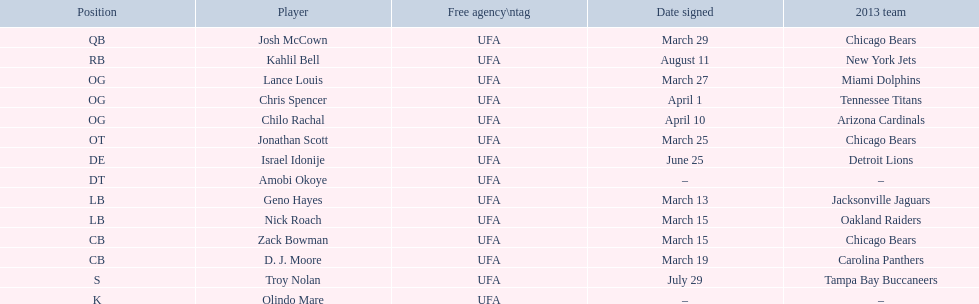How many players signed up in march? 7. Parse the table in full. {'header': ['Position', 'Player', 'Free agency\\ntag', 'Date signed', '2013 team'], 'rows': [['QB', 'Josh McCown', 'UFA', 'March 29', 'Chicago Bears'], ['RB', 'Kahlil Bell', 'UFA', 'August 11', 'New York Jets'], ['OG', 'Lance Louis', 'UFA', 'March 27', 'Miami Dolphins'], ['OG', 'Chris Spencer', 'UFA', 'April 1', 'Tennessee Titans'], ['OG', 'Chilo Rachal', 'UFA', 'April 10', 'Arizona Cardinals'], ['OT', 'Jonathan Scott', 'UFA', 'March 25', 'Chicago Bears'], ['DE', 'Israel Idonije', 'UFA', 'June 25', 'Detroit Lions'], ['DT', 'Amobi Okoye', 'UFA', '–', '–'], ['LB', 'Geno Hayes', 'UFA', 'March 13', 'Jacksonville Jaguars'], ['LB', 'Nick Roach', 'UFA', 'March 15', 'Oakland Raiders'], ['CB', 'Zack Bowman', 'UFA', 'March 15', 'Chicago Bears'], ['CB', 'D. J. Moore', 'UFA', 'March 19', 'Carolina Panthers'], ['S', 'Troy Nolan', 'UFA', 'July 29', 'Tampa Bay Buccaneers'], ['K', 'Olindo Mare', 'UFA', '–', '–']]} 